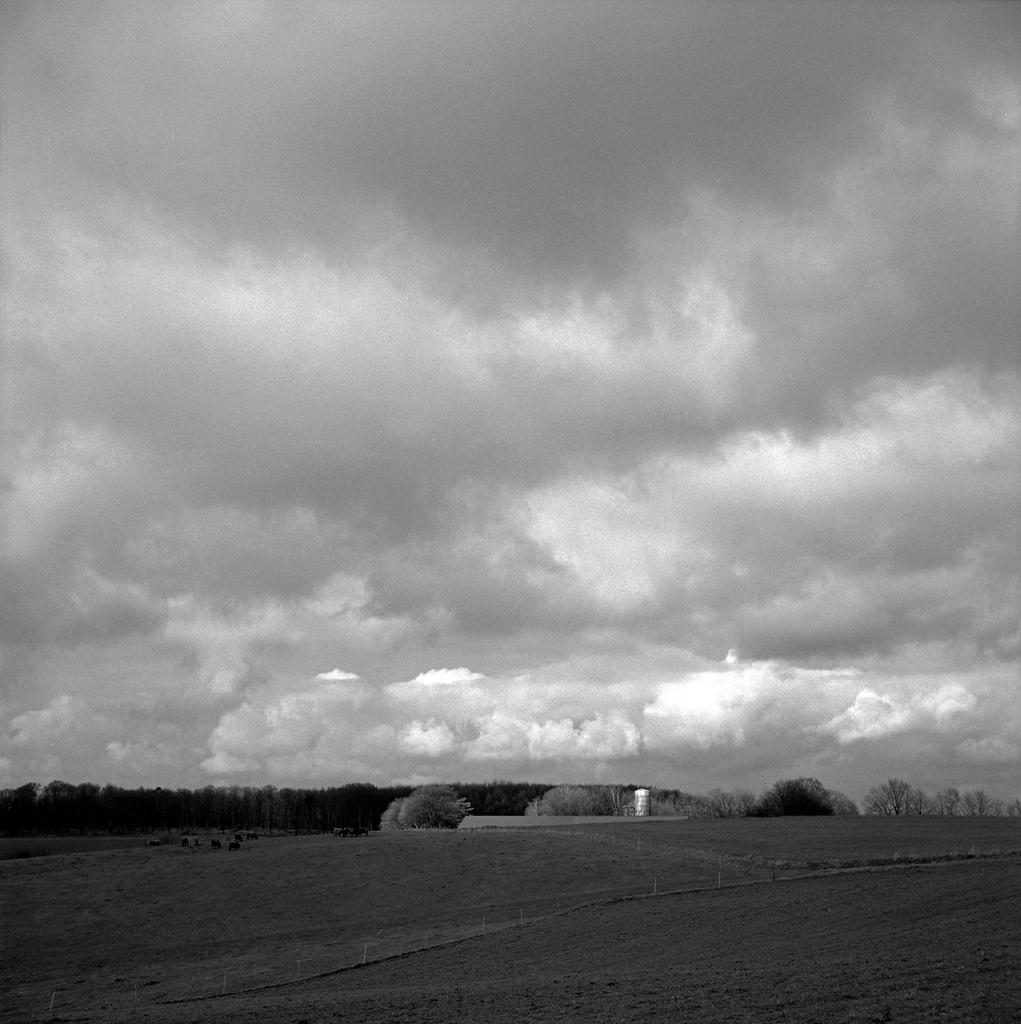What type of vegetation can be seen in the image? There are trees in the image. What color is the prominent object in the image? There is a white color object in the image. Can you identify any living creatures in the image? It appears that there are animals in the image. What type of structures are present in the image? There are poles in the image. What is visible beneath the trees and animals? The ground is visible in the image. How would you describe the weather based on the image? The sky is cloudy in the image. Can you tell me how many snails are crawling on the bread in the image? There is no bread or snails present in the image. What type of beetle can be seen flying near the animals in the image? There are no beetles visible in the image. 